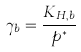<formula> <loc_0><loc_0><loc_500><loc_500>\gamma _ { b } = \frac { K _ { H , b } } { p ^ { * } }</formula> 